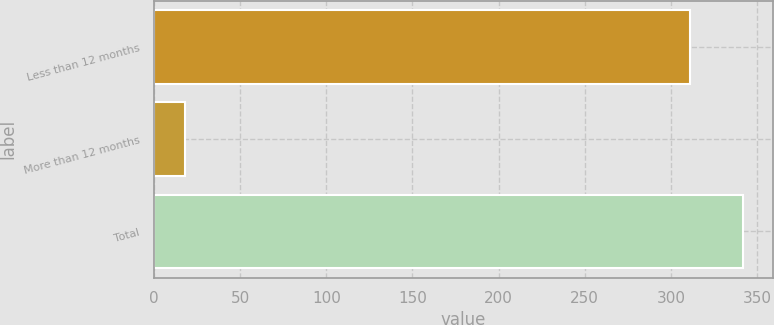Convert chart. <chart><loc_0><loc_0><loc_500><loc_500><bar_chart><fcel>Less than 12 months<fcel>More than 12 months<fcel>Total<nl><fcel>311<fcel>18<fcel>342.1<nl></chart> 